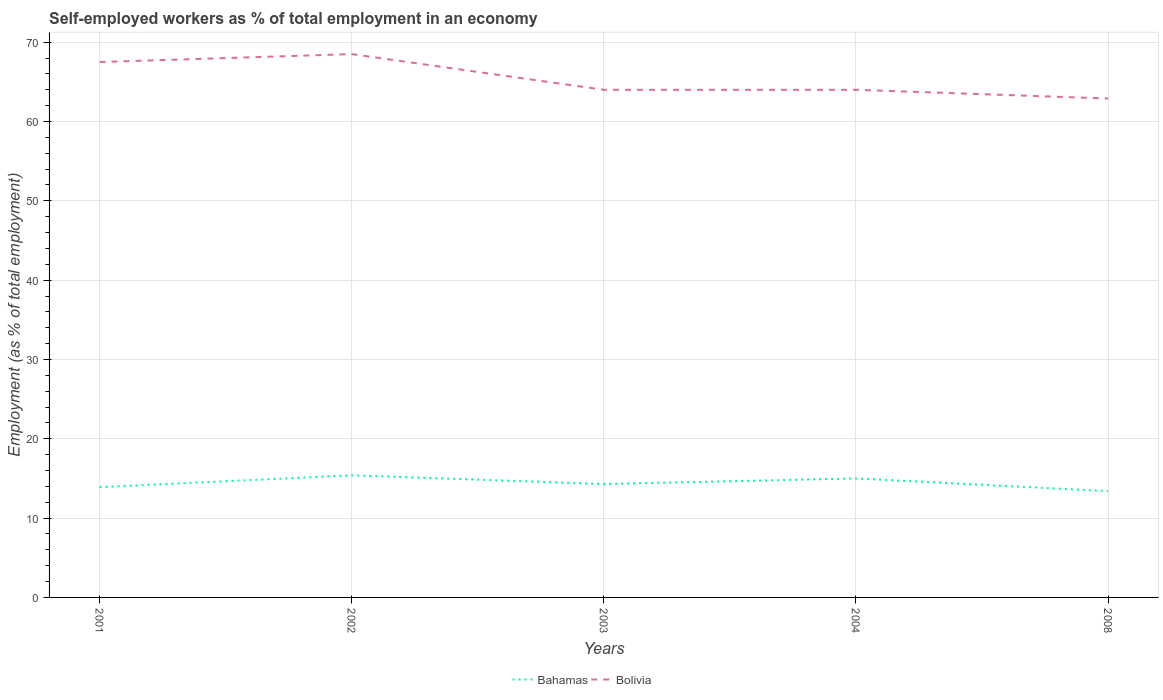How many different coloured lines are there?
Your answer should be very brief. 2. Does the line corresponding to Bolivia intersect with the line corresponding to Bahamas?
Offer a very short reply. No. Across all years, what is the maximum percentage of self-employed workers in Bahamas?
Make the answer very short. 13.4. In which year was the percentage of self-employed workers in Bolivia maximum?
Make the answer very short. 2008. What is the total percentage of self-employed workers in Bahamas in the graph?
Offer a terse response. 1.6. What is the difference between the highest and the second highest percentage of self-employed workers in Bahamas?
Ensure brevity in your answer.  2. How many lines are there?
Keep it short and to the point. 2. What is the difference between two consecutive major ticks on the Y-axis?
Give a very brief answer. 10. Are the values on the major ticks of Y-axis written in scientific E-notation?
Your answer should be compact. No. Where does the legend appear in the graph?
Your answer should be compact. Bottom center. How many legend labels are there?
Offer a terse response. 2. How are the legend labels stacked?
Keep it short and to the point. Horizontal. What is the title of the graph?
Keep it short and to the point. Self-employed workers as % of total employment in an economy. Does "Germany" appear as one of the legend labels in the graph?
Ensure brevity in your answer.  No. What is the label or title of the Y-axis?
Your response must be concise. Employment (as % of total employment). What is the Employment (as % of total employment) of Bahamas in 2001?
Keep it short and to the point. 13.9. What is the Employment (as % of total employment) in Bolivia in 2001?
Provide a succinct answer. 67.5. What is the Employment (as % of total employment) in Bahamas in 2002?
Provide a succinct answer. 15.4. What is the Employment (as % of total employment) of Bolivia in 2002?
Provide a short and direct response. 68.5. What is the Employment (as % of total employment) of Bahamas in 2003?
Offer a very short reply. 14.3. What is the Employment (as % of total employment) in Bolivia in 2003?
Offer a terse response. 64. What is the Employment (as % of total employment) in Bahamas in 2004?
Provide a short and direct response. 15. What is the Employment (as % of total employment) in Bolivia in 2004?
Provide a short and direct response. 64. What is the Employment (as % of total employment) in Bahamas in 2008?
Provide a succinct answer. 13.4. What is the Employment (as % of total employment) in Bolivia in 2008?
Offer a very short reply. 62.9. Across all years, what is the maximum Employment (as % of total employment) of Bahamas?
Provide a short and direct response. 15.4. Across all years, what is the maximum Employment (as % of total employment) in Bolivia?
Keep it short and to the point. 68.5. Across all years, what is the minimum Employment (as % of total employment) of Bahamas?
Your answer should be compact. 13.4. Across all years, what is the minimum Employment (as % of total employment) in Bolivia?
Offer a very short reply. 62.9. What is the total Employment (as % of total employment) in Bahamas in the graph?
Provide a succinct answer. 72. What is the total Employment (as % of total employment) in Bolivia in the graph?
Provide a short and direct response. 326.9. What is the difference between the Employment (as % of total employment) in Bahamas in 2001 and that in 2002?
Your answer should be compact. -1.5. What is the difference between the Employment (as % of total employment) in Bolivia in 2001 and that in 2002?
Provide a succinct answer. -1. What is the difference between the Employment (as % of total employment) of Bahamas in 2001 and that in 2003?
Ensure brevity in your answer.  -0.4. What is the difference between the Employment (as % of total employment) in Bolivia in 2001 and that in 2003?
Make the answer very short. 3.5. What is the difference between the Employment (as % of total employment) in Bahamas in 2001 and that in 2004?
Provide a short and direct response. -1.1. What is the difference between the Employment (as % of total employment) in Bolivia in 2001 and that in 2008?
Ensure brevity in your answer.  4.6. What is the difference between the Employment (as % of total employment) of Bahamas in 2002 and that in 2003?
Your response must be concise. 1.1. What is the difference between the Employment (as % of total employment) in Bolivia in 2002 and that in 2003?
Your answer should be compact. 4.5. What is the difference between the Employment (as % of total employment) in Bahamas in 2002 and that in 2004?
Your answer should be very brief. 0.4. What is the difference between the Employment (as % of total employment) of Bolivia in 2002 and that in 2004?
Your answer should be very brief. 4.5. What is the difference between the Employment (as % of total employment) of Bahamas in 2002 and that in 2008?
Ensure brevity in your answer.  2. What is the difference between the Employment (as % of total employment) of Bahamas in 2001 and the Employment (as % of total employment) of Bolivia in 2002?
Offer a terse response. -54.6. What is the difference between the Employment (as % of total employment) in Bahamas in 2001 and the Employment (as % of total employment) in Bolivia in 2003?
Your answer should be very brief. -50.1. What is the difference between the Employment (as % of total employment) in Bahamas in 2001 and the Employment (as % of total employment) in Bolivia in 2004?
Offer a very short reply. -50.1. What is the difference between the Employment (as % of total employment) in Bahamas in 2001 and the Employment (as % of total employment) in Bolivia in 2008?
Keep it short and to the point. -49. What is the difference between the Employment (as % of total employment) of Bahamas in 2002 and the Employment (as % of total employment) of Bolivia in 2003?
Your response must be concise. -48.6. What is the difference between the Employment (as % of total employment) of Bahamas in 2002 and the Employment (as % of total employment) of Bolivia in 2004?
Give a very brief answer. -48.6. What is the difference between the Employment (as % of total employment) of Bahamas in 2002 and the Employment (as % of total employment) of Bolivia in 2008?
Your answer should be compact. -47.5. What is the difference between the Employment (as % of total employment) in Bahamas in 2003 and the Employment (as % of total employment) in Bolivia in 2004?
Offer a very short reply. -49.7. What is the difference between the Employment (as % of total employment) of Bahamas in 2003 and the Employment (as % of total employment) of Bolivia in 2008?
Provide a short and direct response. -48.6. What is the difference between the Employment (as % of total employment) in Bahamas in 2004 and the Employment (as % of total employment) in Bolivia in 2008?
Provide a short and direct response. -47.9. What is the average Employment (as % of total employment) of Bahamas per year?
Provide a short and direct response. 14.4. What is the average Employment (as % of total employment) of Bolivia per year?
Provide a succinct answer. 65.38. In the year 2001, what is the difference between the Employment (as % of total employment) of Bahamas and Employment (as % of total employment) of Bolivia?
Keep it short and to the point. -53.6. In the year 2002, what is the difference between the Employment (as % of total employment) in Bahamas and Employment (as % of total employment) in Bolivia?
Your answer should be compact. -53.1. In the year 2003, what is the difference between the Employment (as % of total employment) of Bahamas and Employment (as % of total employment) of Bolivia?
Your response must be concise. -49.7. In the year 2004, what is the difference between the Employment (as % of total employment) of Bahamas and Employment (as % of total employment) of Bolivia?
Offer a very short reply. -49. In the year 2008, what is the difference between the Employment (as % of total employment) of Bahamas and Employment (as % of total employment) of Bolivia?
Ensure brevity in your answer.  -49.5. What is the ratio of the Employment (as % of total employment) in Bahamas in 2001 to that in 2002?
Offer a terse response. 0.9. What is the ratio of the Employment (as % of total employment) in Bolivia in 2001 to that in 2002?
Your answer should be compact. 0.99. What is the ratio of the Employment (as % of total employment) in Bahamas in 2001 to that in 2003?
Offer a very short reply. 0.97. What is the ratio of the Employment (as % of total employment) of Bolivia in 2001 to that in 2003?
Your answer should be very brief. 1.05. What is the ratio of the Employment (as % of total employment) in Bahamas in 2001 to that in 2004?
Provide a short and direct response. 0.93. What is the ratio of the Employment (as % of total employment) in Bolivia in 2001 to that in 2004?
Keep it short and to the point. 1.05. What is the ratio of the Employment (as % of total employment) of Bahamas in 2001 to that in 2008?
Provide a succinct answer. 1.04. What is the ratio of the Employment (as % of total employment) of Bolivia in 2001 to that in 2008?
Keep it short and to the point. 1.07. What is the ratio of the Employment (as % of total employment) in Bolivia in 2002 to that in 2003?
Make the answer very short. 1.07. What is the ratio of the Employment (as % of total employment) in Bahamas in 2002 to that in 2004?
Your answer should be very brief. 1.03. What is the ratio of the Employment (as % of total employment) in Bolivia in 2002 to that in 2004?
Your response must be concise. 1.07. What is the ratio of the Employment (as % of total employment) in Bahamas in 2002 to that in 2008?
Your answer should be very brief. 1.15. What is the ratio of the Employment (as % of total employment) in Bolivia in 2002 to that in 2008?
Your response must be concise. 1.09. What is the ratio of the Employment (as % of total employment) in Bahamas in 2003 to that in 2004?
Provide a succinct answer. 0.95. What is the ratio of the Employment (as % of total employment) in Bolivia in 2003 to that in 2004?
Provide a short and direct response. 1. What is the ratio of the Employment (as % of total employment) of Bahamas in 2003 to that in 2008?
Provide a short and direct response. 1.07. What is the ratio of the Employment (as % of total employment) of Bolivia in 2003 to that in 2008?
Your answer should be compact. 1.02. What is the ratio of the Employment (as % of total employment) of Bahamas in 2004 to that in 2008?
Provide a succinct answer. 1.12. What is the ratio of the Employment (as % of total employment) of Bolivia in 2004 to that in 2008?
Make the answer very short. 1.02. What is the difference between the highest and the second highest Employment (as % of total employment) of Bahamas?
Provide a short and direct response. 0.4. What is the difference between the highest and the second highest Employment (as % of total employment) in Bolivia?
Keep it short and to the point. 1. 